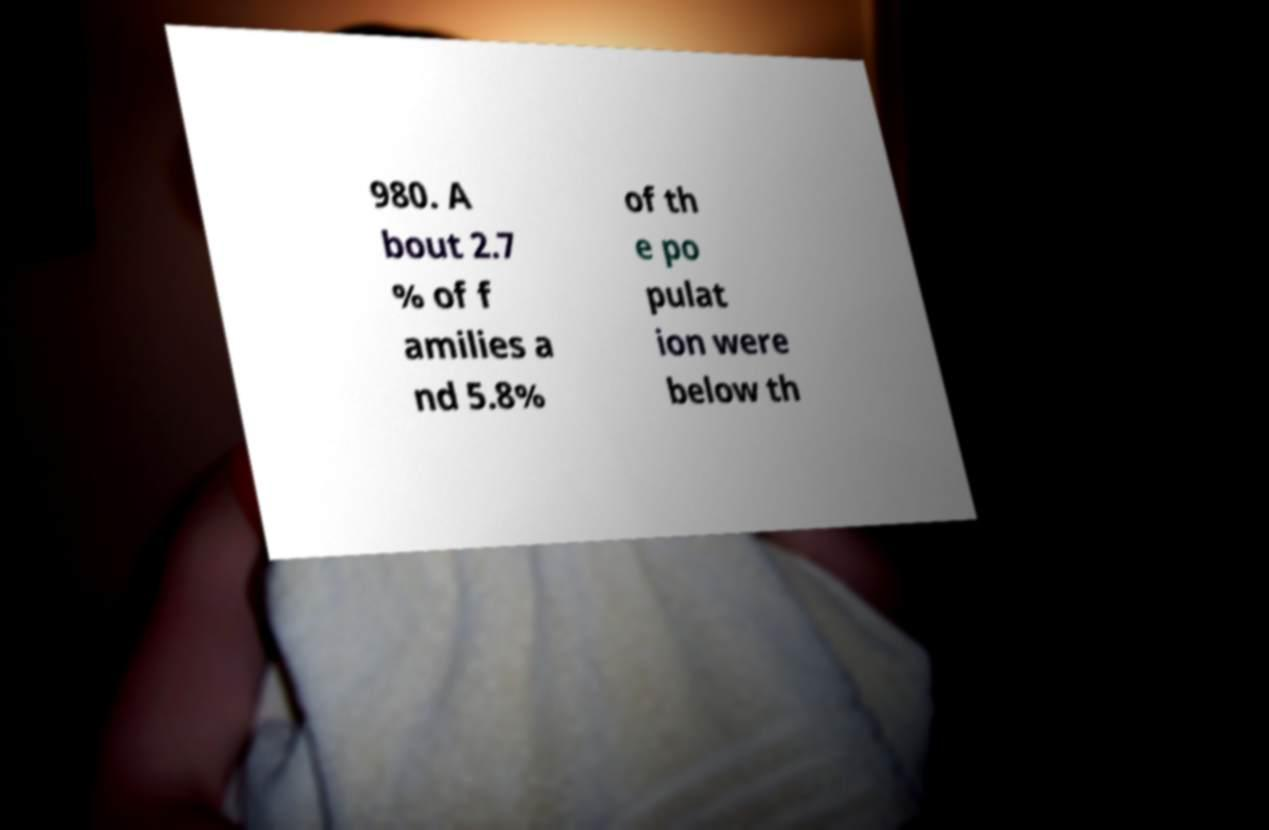Please identify and transcribe the text found in this image. 980. A bout 2.7 % of f amilies a nd 5.8% of th e po pulat ion were below th 